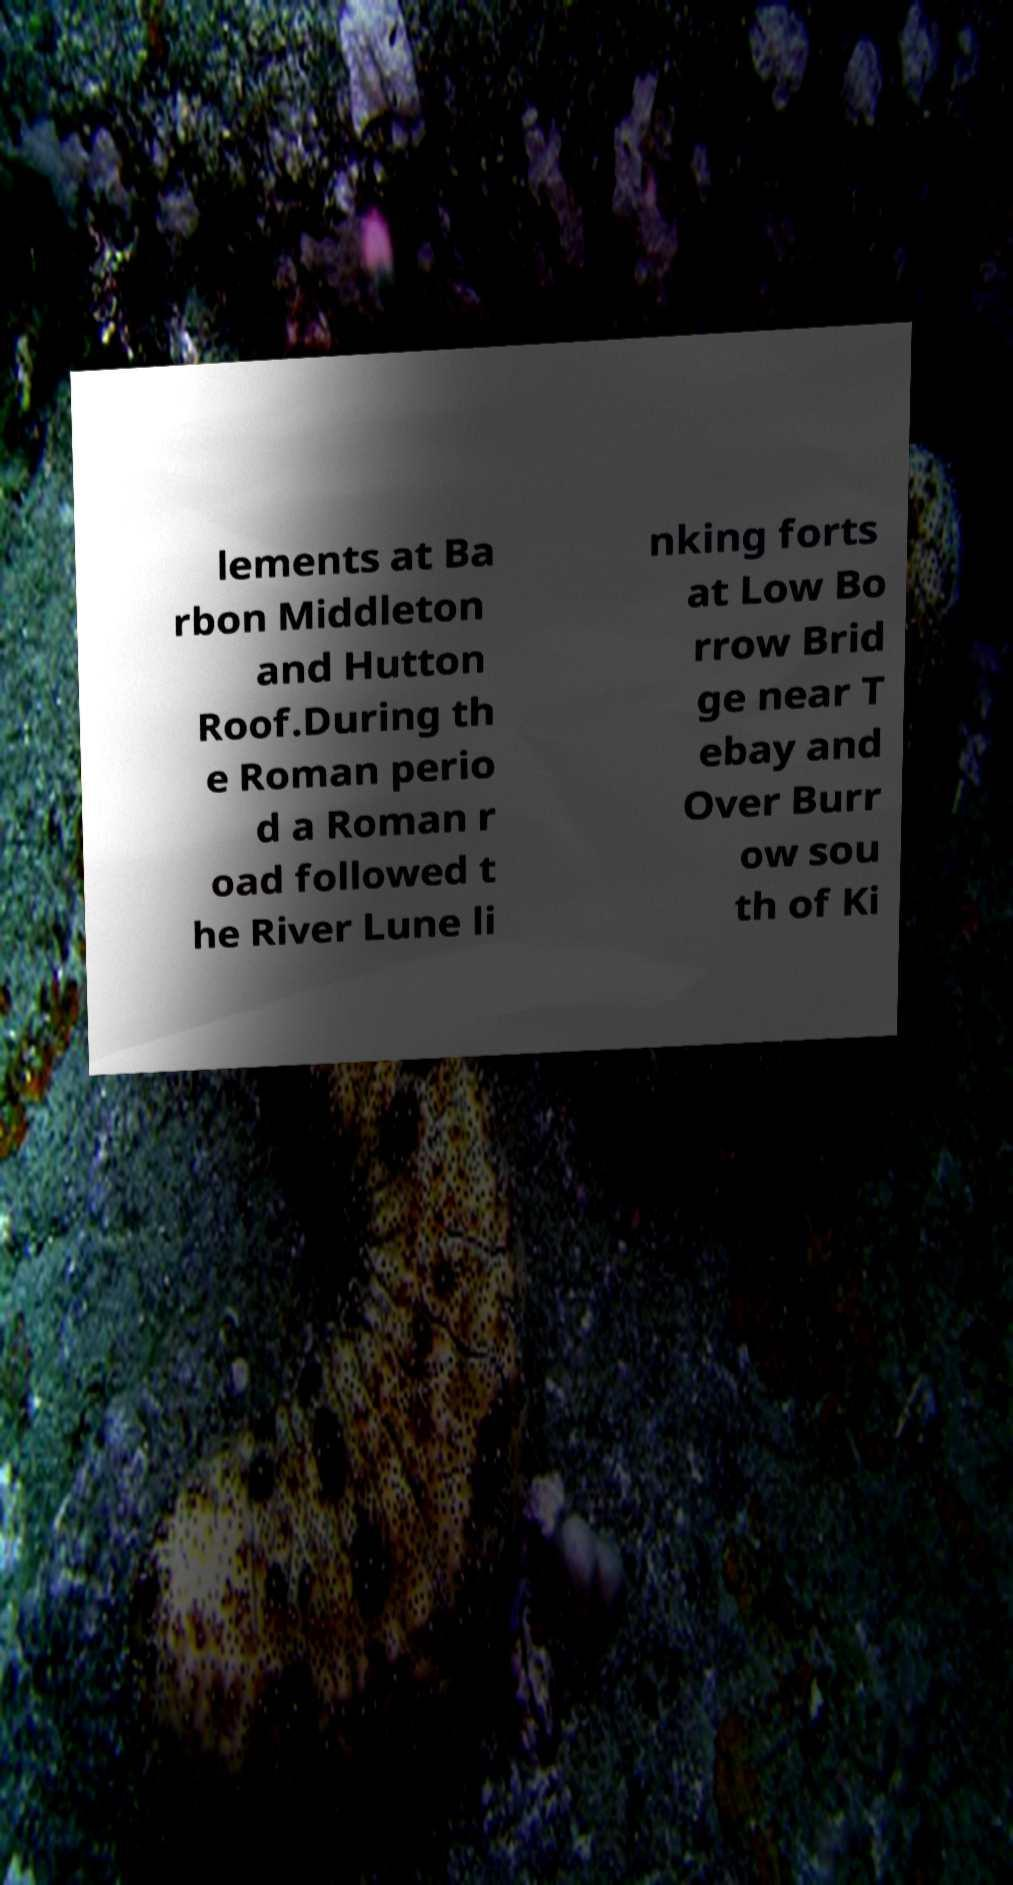What messages or text are displayed in this image? I need them in a readable, typed format. lements at Ba rbon Middleton and Hutton Roof.During th e Roman perio d a Roman r oad followed t he River Lune li nking forts at Low Bo rrow Brid ge near T ebay and Over Burr ow sou th of Ki 